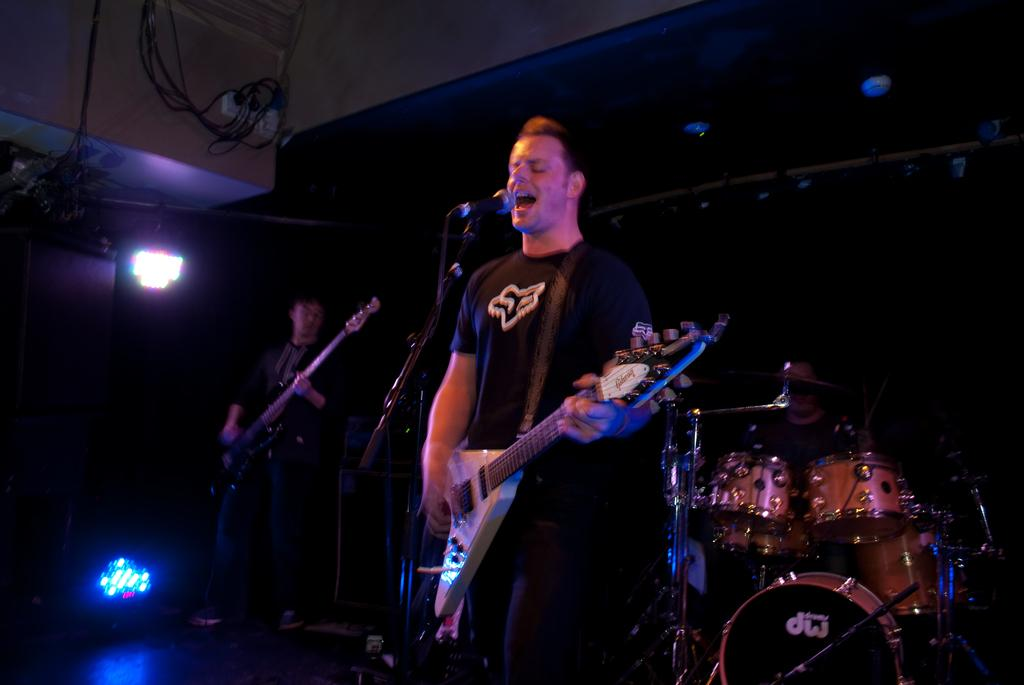What is the man in the image doing? The man is playing a guitar in the image. What other musical instrument can be seen in the background of the image? There are drums in the background of the image. What type of lighting is present in the background of the image? There is a focus light in the background of the image. Are there any other people in the image? Yes, there is another man standing in the background of the image. What is the second man in the image doing? The second man is also playing a guitar in the image. How many birds are perched on the guitar in the image? There are no birds present in the image, so it is not possible to determine how many might be perched on the guitar. 